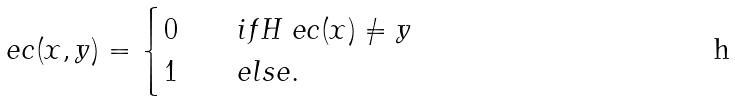Convert formula to latex. <formula><loc_0><loc_0><loc_500><loc_500>\ e c ( x , y ) = \begin{cases} 0 \quad & i f H _ { \ } e c ( x ) \neq y \\ 1 \quad & e l s e . \end{cases}</formula> 